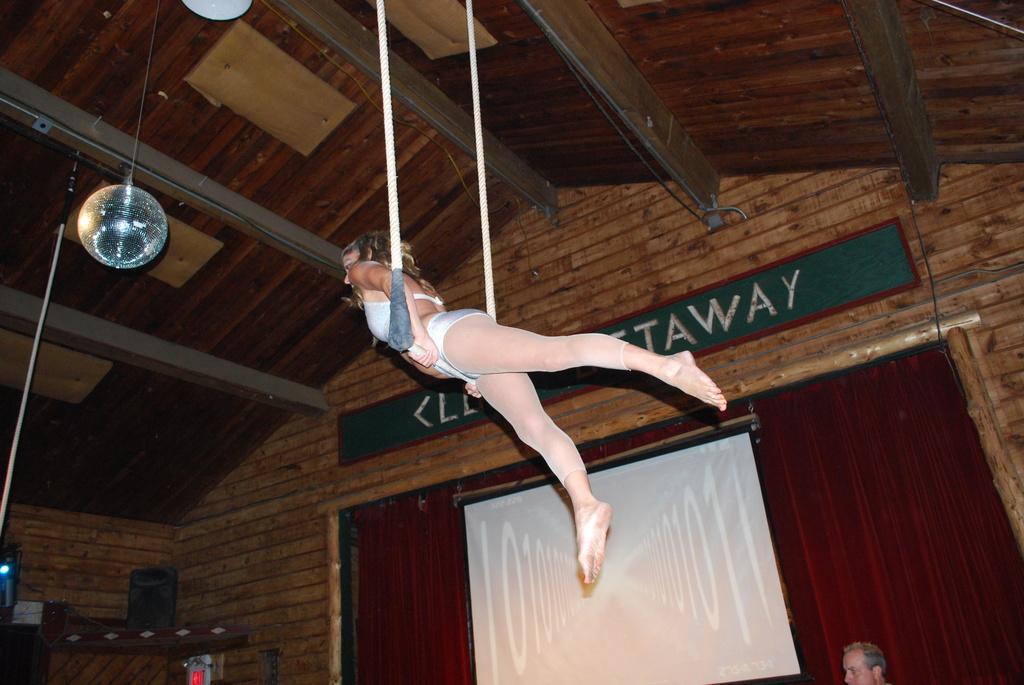Please provide a concise description of this image. In the image there is a lady holding the rod and she is standing in the air. And also there are ropes. At the top of the image there is ceiling with wooden poles and roofs. And also there are few things hanging. At the bottom of the image there is a head of a person. And also there is a screen. Behind the screen there is a curtain. And on the left side of the image there is a cupboard with few things. 